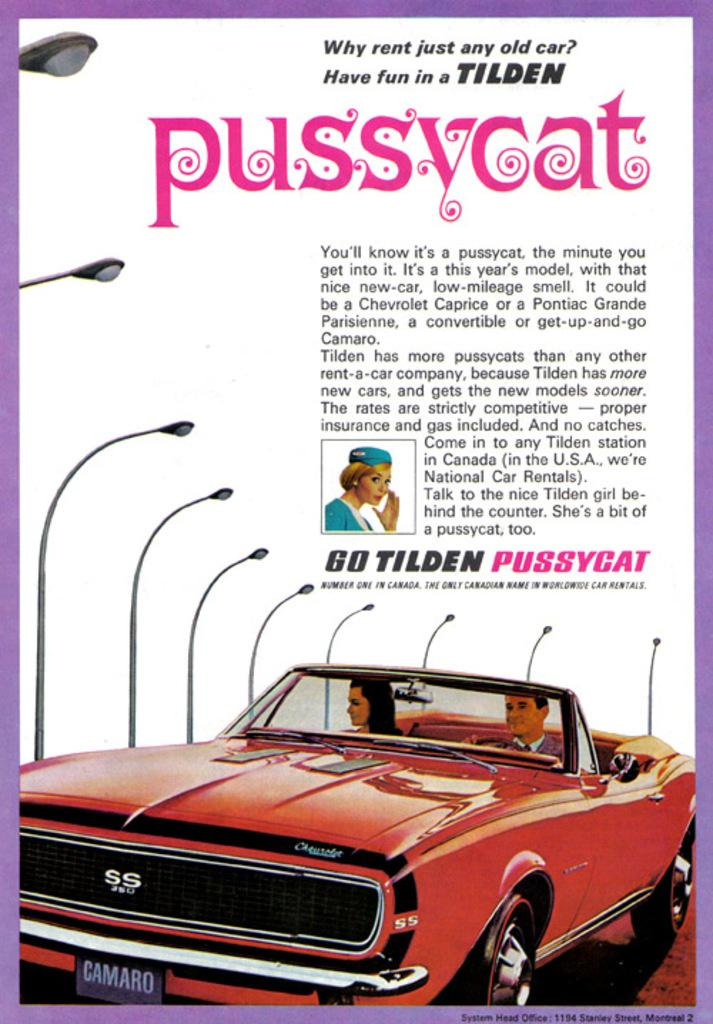What is happening in the picture in the image? There is a picture of two persons riding a car. What can be seen in the background of the image? There is a group of light poles in the background. Are there any words or letters on the light poles? Yes, there is some text on the light poles. What type of cup is being used to cover the shame of the two persons riding the car in the image? There is no cup or any indication of shame present in the image. 